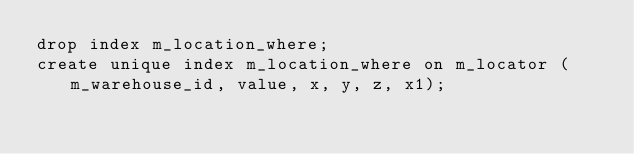<code> <loc_0><loc_0><loc_500><loc_500><_SQL_>drop index m_location_where;
create unique index m_location_where on m_locator (m_warehouse_id, value, x, y, z, x1);</code> 